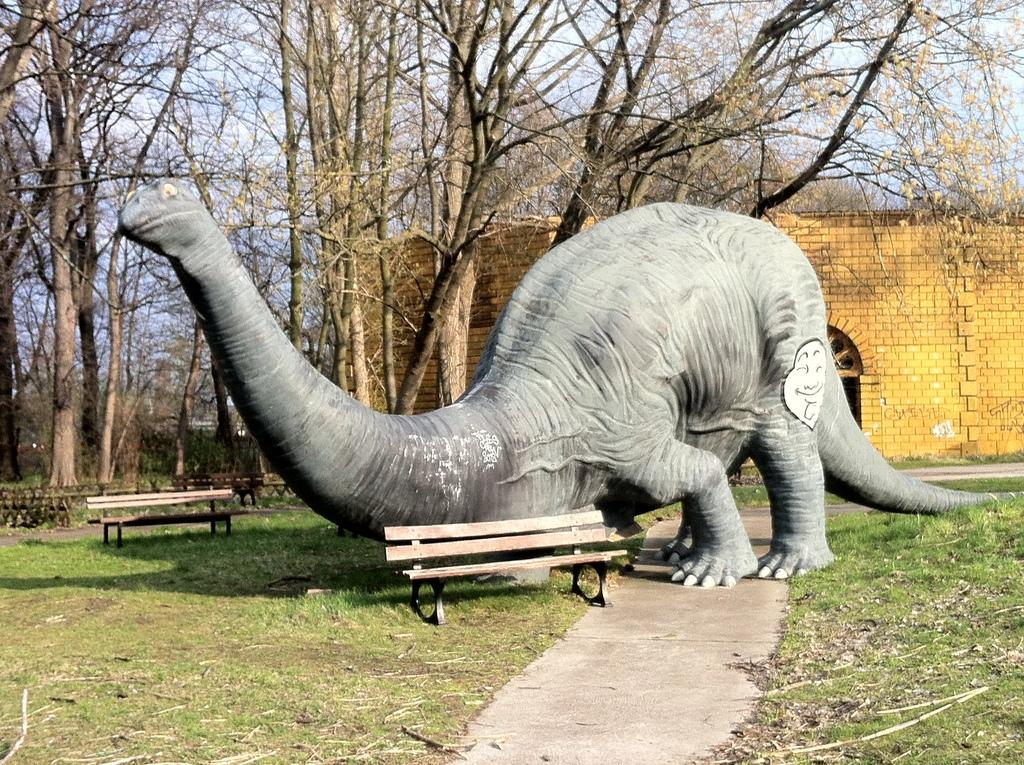What is the main subject of the image? There is a statue of a dinosaur in the image. What can be found near the statue? There are benches in the image. What type of structure is visible in the image? There is a building in the image. What type of vegetation is present in the image? The grass and trees are visible in the image. What is visible in the background of the image? The sky is visible in the background of the image. What rhythm is the statue attempting to convey in the image? The statue is not attempting to convey any rhythm, as it is a static object and not capable of conveying rhythm. 